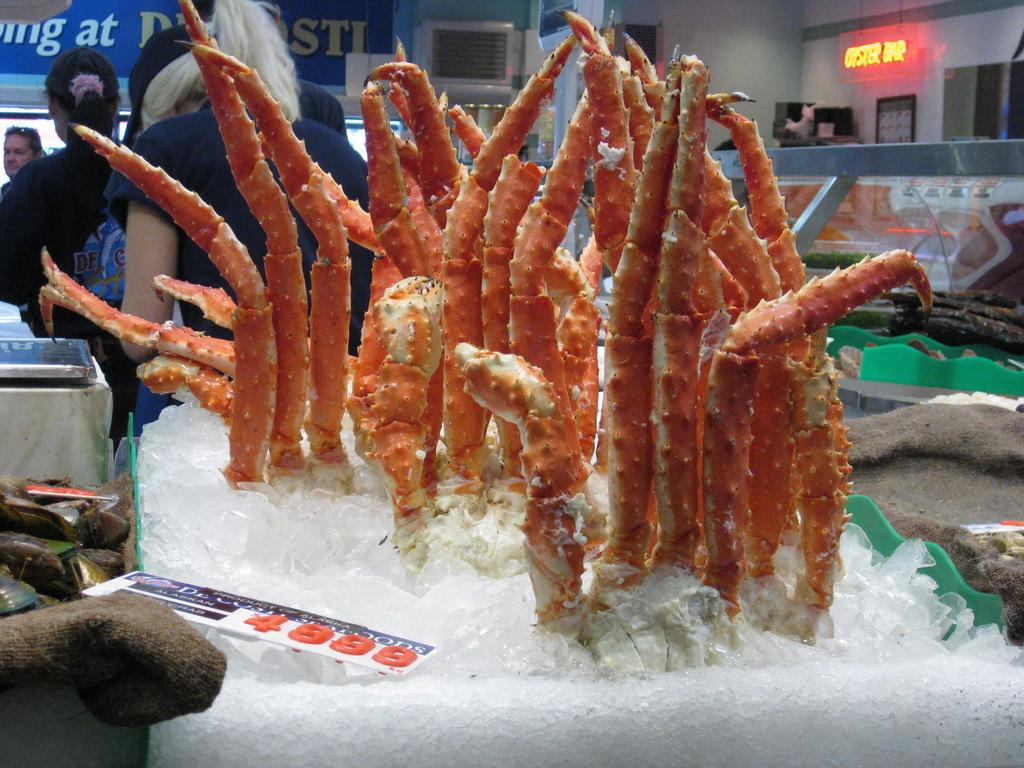What is placed in the ice in the center of the image? There are carbs placed in the ice in the center of the image. What can be seen on the left side of the image? There are boards and a table on the left side of the image. What is visible in the background of the image? There are people standing in the background of the image, and there is a wall in the background as well. How many cushions are placed on the apples in the image? There are no cushions or apples present in the image. 